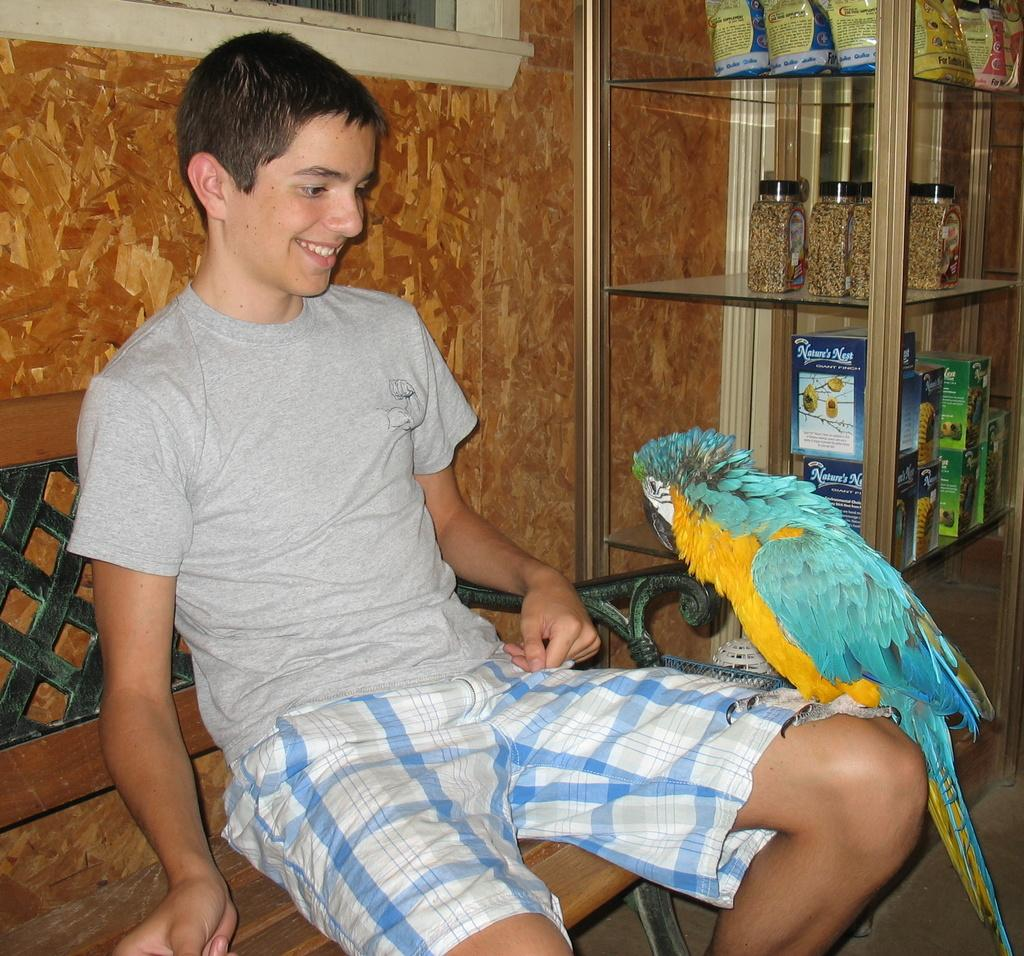What is the person in the image doing? There is a person sitting on a bench in the image. What animal can be seen in the image? There is a bird in the image. What type of containers are present in the image? There are glass containers in the image. What are the packets stored in? The packets are stored in glass racks in the image. What type of structure is visible in the image? There is a wall in the image. What feature allows natural light to enter the space? There is a window in the image. How many giants can be seen in the image? There are no giants present in the image. What word is written on the bird's beak in the image? There are no words written on the bird's beak in the image. 